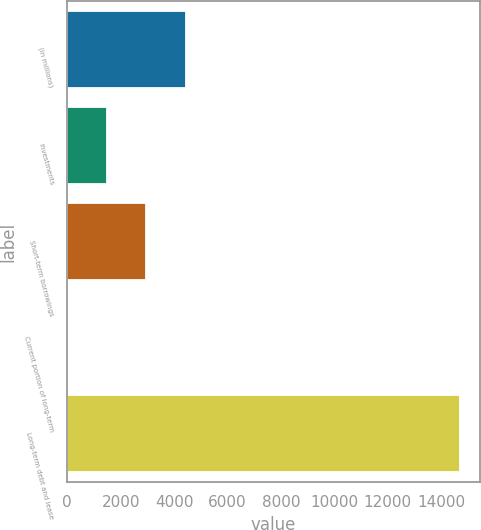Convert chart. <chart><loc_0><loc_0><loc_500><loc_500><bar_chart><fcel>(in millions)<fcel>Investments<fcel>Short-term borrowings<fcel>Current portion of long-term<fcel>Long-term debt and lease<nl><fcel>4428.7<fcel>1490.9<fcel>2959.8<fcel>22<fcel>14711<nl></chart> 